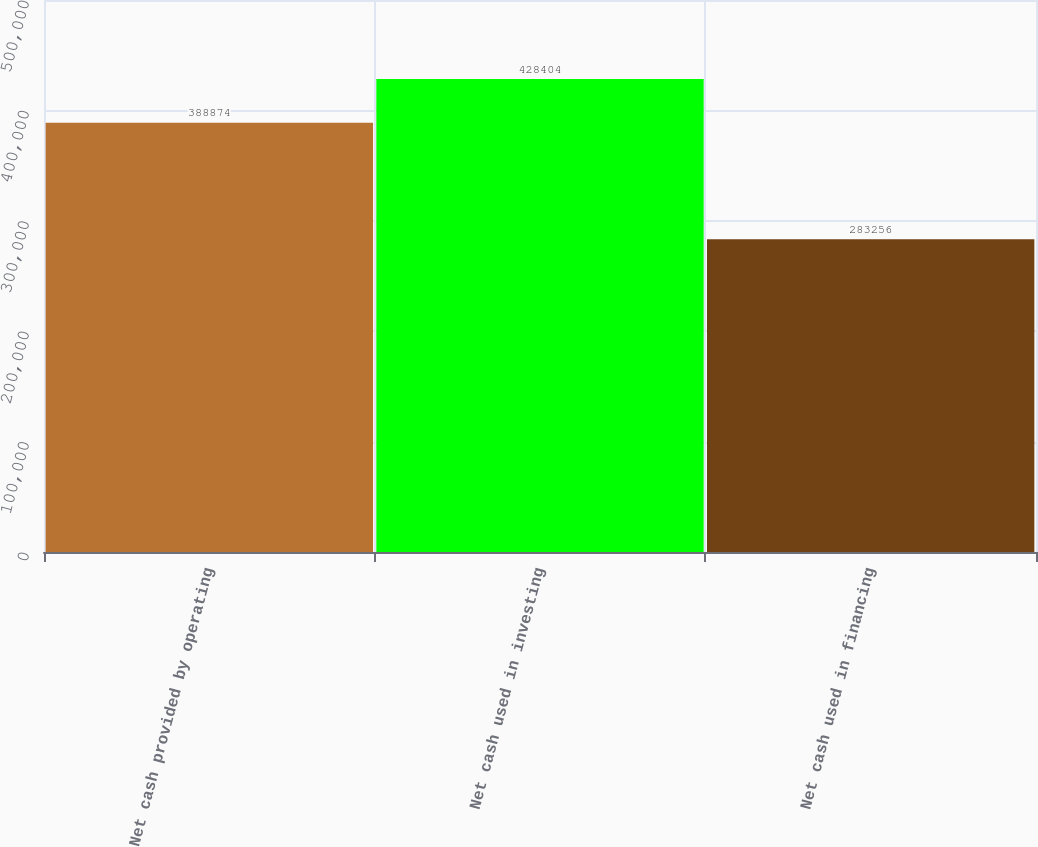Convert chart to OTSL. <chart><loc_0><loc_0><loc_500><loc_500><bar_chart><fcel>Net cash provided by operating<fcel>Net cash used in investing<fcel>Net cash used in financing<nl><fcel>388874<fcel>428404<fcel>283256<nl></chart> 